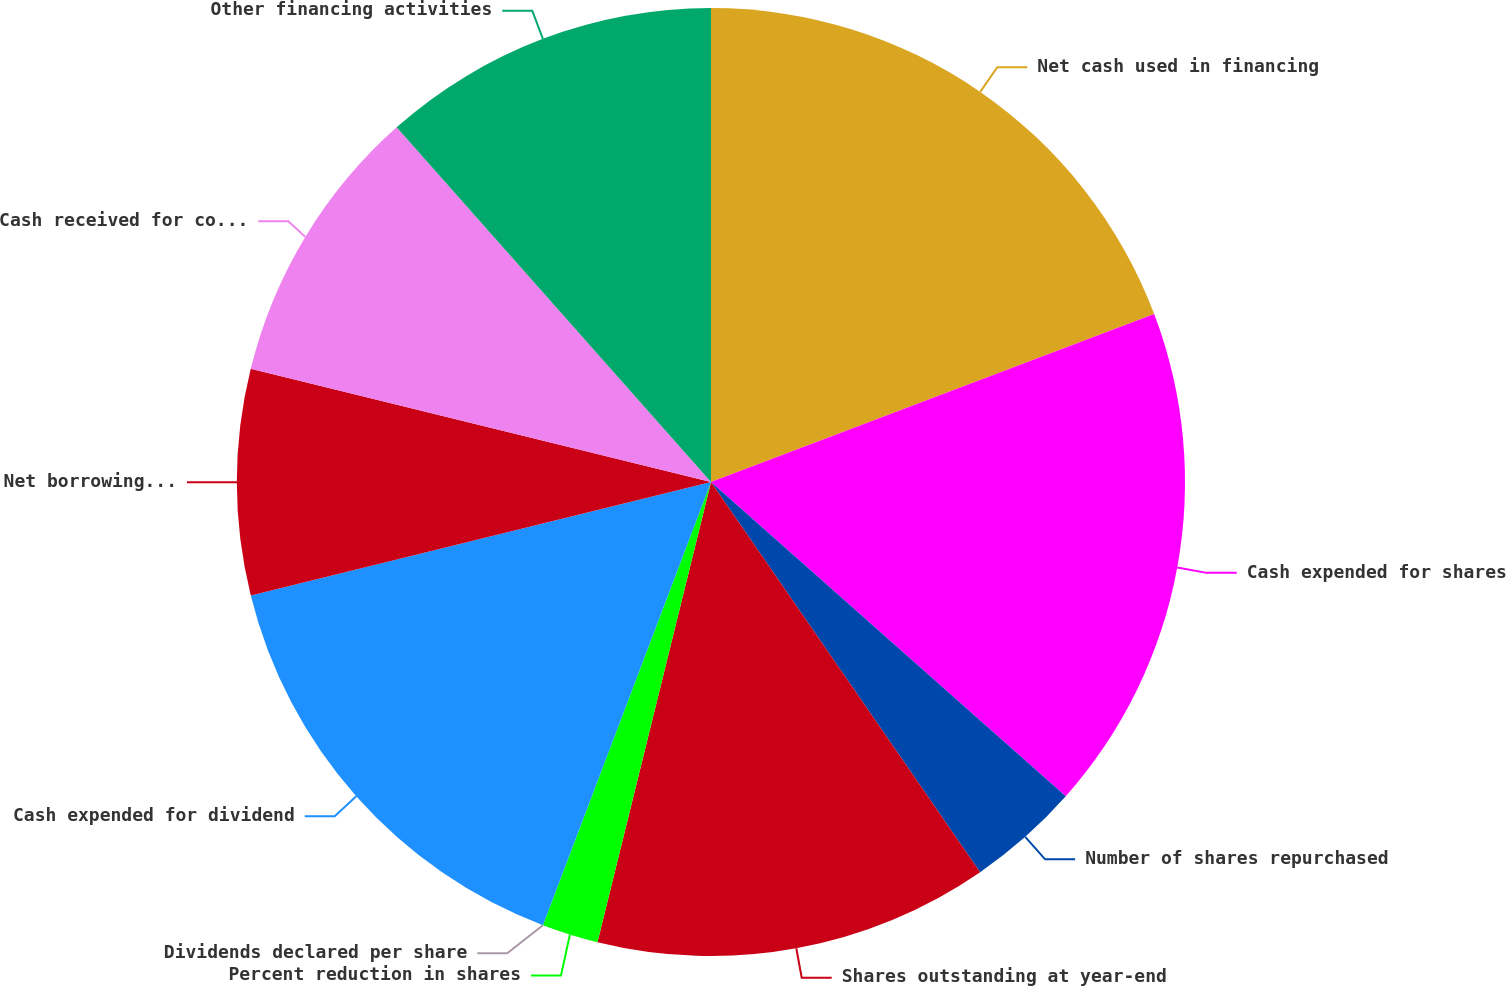<chart> <loc_0><loc_0><loc_500><loc_500><pie_chart><fcel>Net cash used in financing<fcel>Cash expended for shares<fcel>Number of shares repurchased<fcel>Shares outstanding at year-end<fcel>Percent reduction in shares<fcel>Dividends declared per share<fcel>Cash expended for dividend<fcel>Net borrowings (repayments) of<fcel>Cash received for common stock<fcel>Other financing activities<nl><fcel>19.23%<fcel>17.31%<fcel>3.85%<fcel>13.46%<fcel>1.92%<fcel>0.0%<fcel>15.38%<fcel>7.69%<fcel>9.62%<fcel>11.54%<nl></chart> 